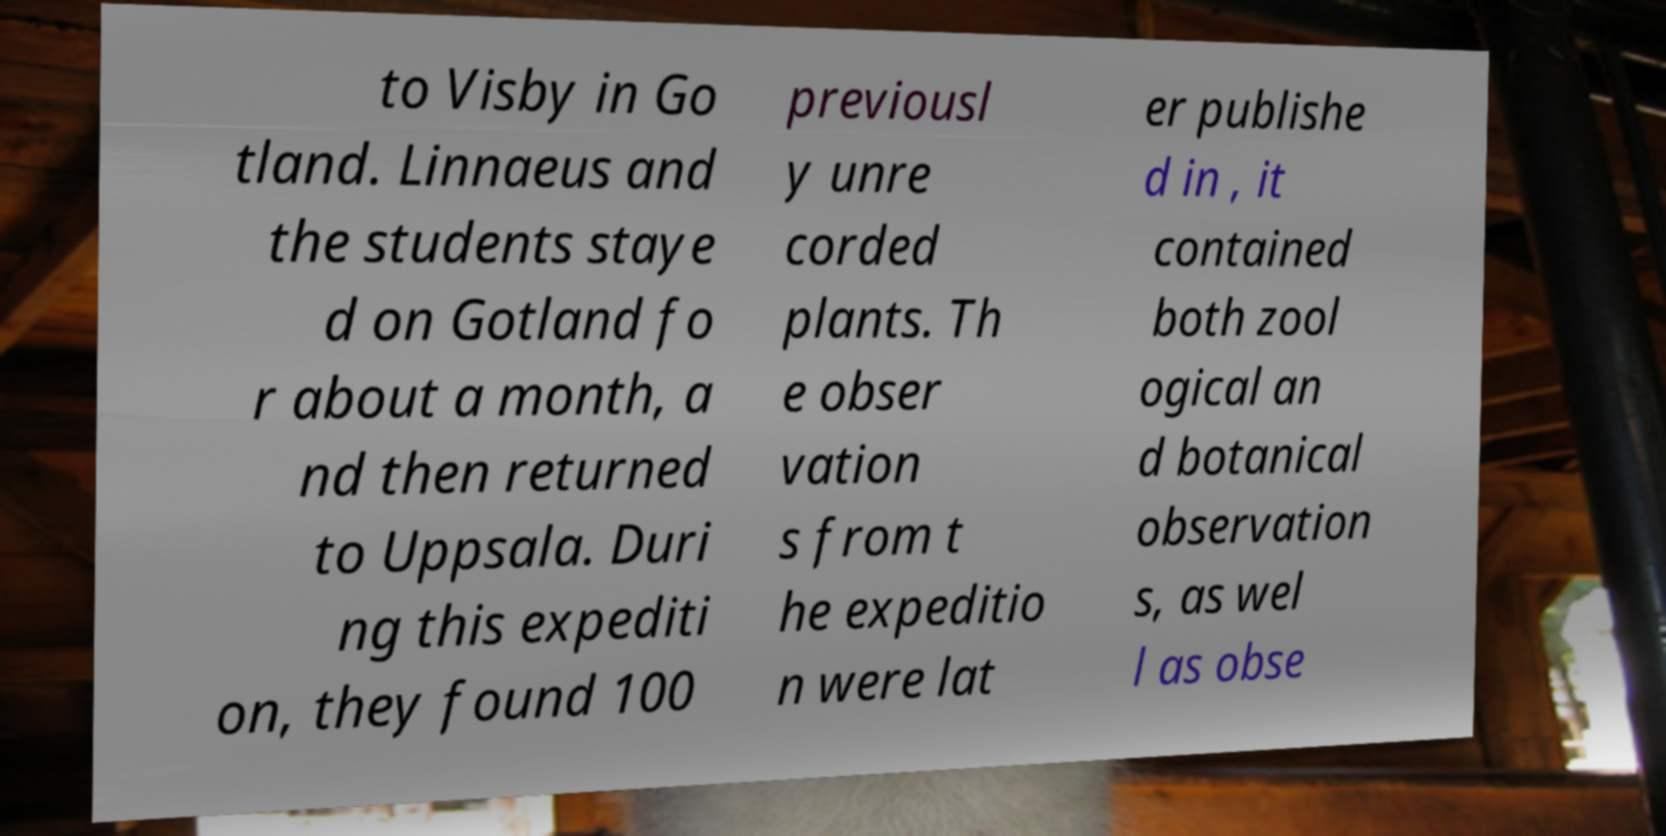For documentation purposes, I need the text within this image transcribed. Could you provide that? to Visby in Go tland. Linnaeus and the students staye d on Gotland fo r about a month, a nd then returned to Uppsala. Duri ng this expediti on, they found 100 previousl y unre corded plants. Th e obser vation s from t he expeditio n were lat er publishe d in , it contained both zool ogical an d botanical observation s, as wel l as obse 